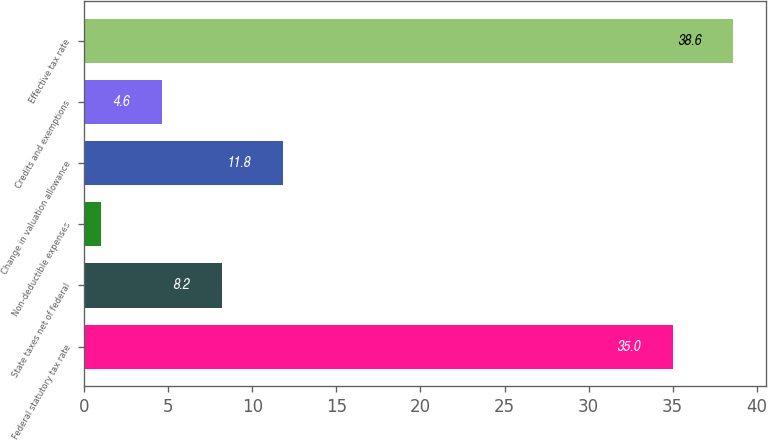Convert chart to OTSL. <chart><loc_0><loc_0><loc_500><loc_500><bar_chart><fcel>Federal statutory tax rate<fcel>State taxes net of federal<fcel>Non-deductible expenses<fcel>Change in valuation allowance<fcel>Credits and exemptions<fcel>Effective tax rate<nl><fcel>35<fcel>8.2<fcel>1<fcel>11.8<fcel>4.6<fcel>38.6<nl></chart> 